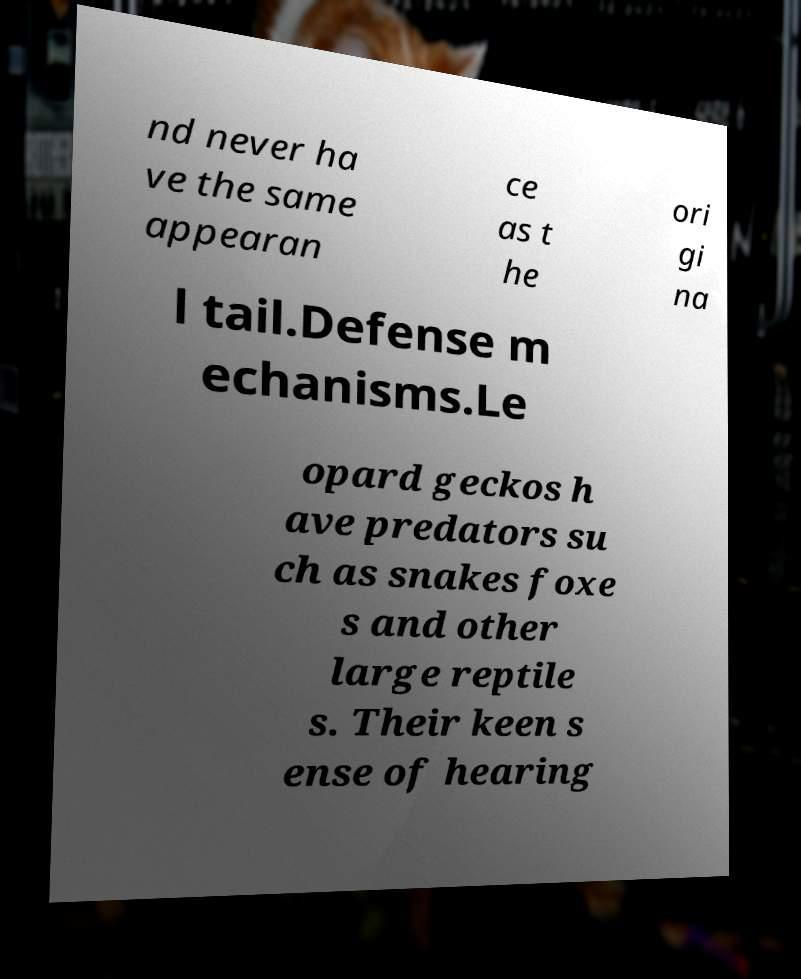Could you extract and type out the text from this image? nd never ha ve the same appearan ce as t he ori gi na l tail.Defense m echanisms.Le opard geckos h ave predators su ch as snakes foxe s and other large reptile s. Their keen s ense of hearing 